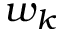Convert formula to latex. <formula><loc_0><loc_0><loc_500><loc_500>w _ { k }</formula> 